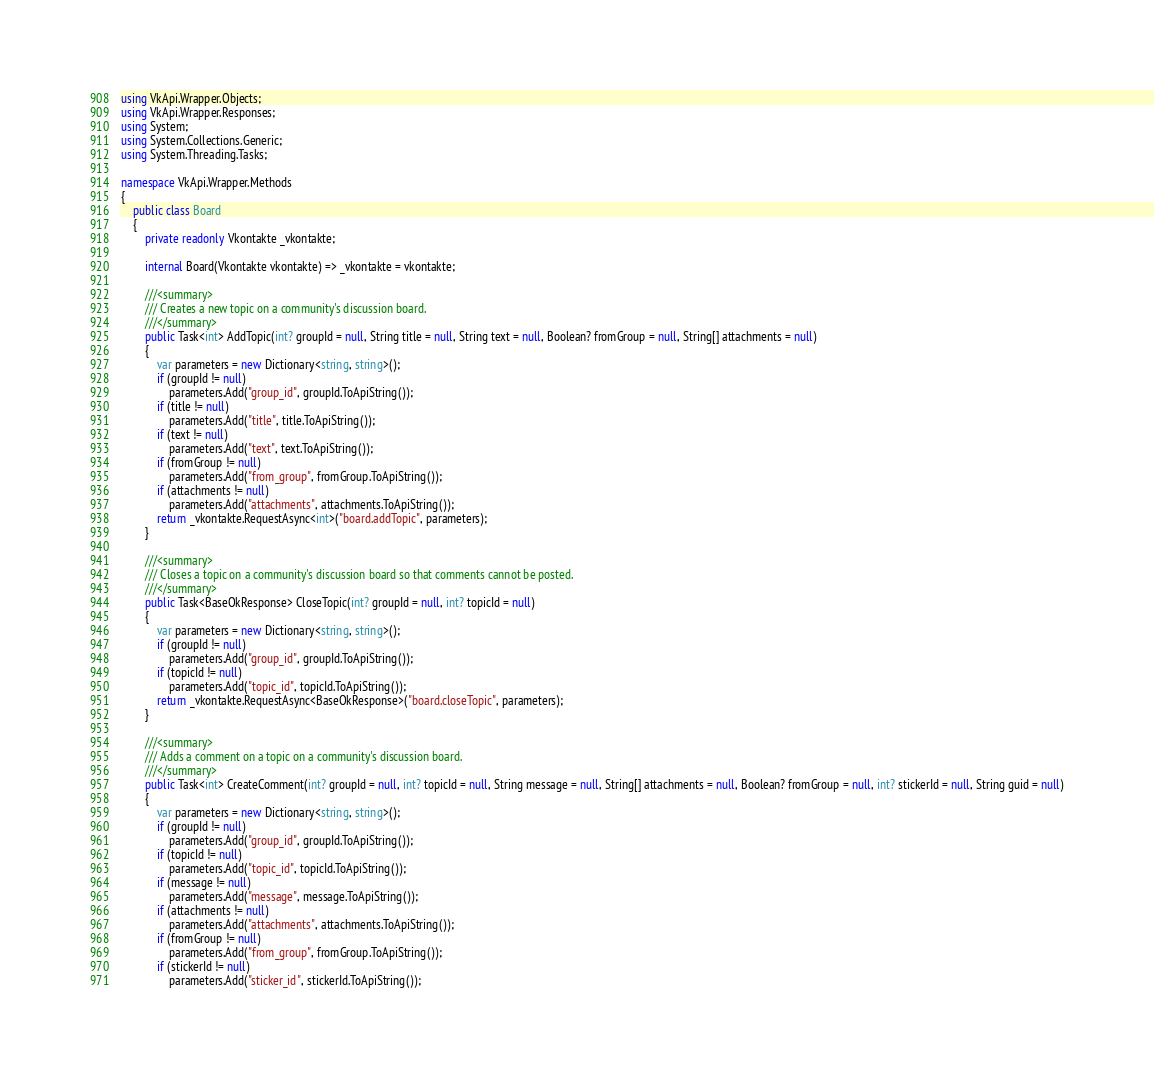Convert code to text. <code><loc_0><loc_0><loc_500><loc_500><_C#_>using VkApi.Wrapper.Objects;
using VkApi.Wrapper.Responses;
using System;
using System.Collections.Generic;
using System.Threading.Tasks;

namespace VkApi.Wrapper.Methods
{
    public class Board
    {
        private readonly Vkontakte _vkontakte;

        internal Board(Vkontakte vkontakte) => _vkontakte = vkontakte;

        ///<summary>
        /// Creates a new topic on a community's discussion board.
        ///</summary>
        public Task<int> AddTopic(int? groupId = null, String title = null, String text = null, Boolean? fromGroup = null, String[] attachments = null)
        {
            var parameters = new Dictionary<string, string>();
            if (groupId != null)
                parameters.Add("group_id", groupId.ToApiString());
            if (title != null)
                parameters.Add("title", title.ToApiString());
            if (text != null)
                parameters.Add("text", text.ToApiString());
            if (fromGroup != null)
                parameters.Add("from_group", fromGroup.ToApiString());
            if (attachments != null)
                parameters.Add("attachments", attachments.ToApiString());
            return _vkontakte.RequestAsync<int>("board.addTopic", parameters);
        }

        ///<summary>
        /// Closes a topic on a community's discussion board so that comments cannot be posted.
        ///</summary>
        public Task<BaseOkResponse> CloseTopic(int? groupId = null, int? topicId = null)
        {
            var parameters = new Dictionary<string, string>();
            if (groupId != null)
                parameters.Add("group_id", groupId.ToApiString());
            if (topicId != null)
                parameters.Add("topic_id", topicId.ToApiString());
            return _vkontakte.RequestAsync<BaseOkResponse>("board.closeTopic", parameters);
        }

        ///<summary>
        /// Adds a comment on a topic on a community's discussion board.
        ///</summary>
        public Task<int> CreateComment(int? groupId = null, int? topicId = null, String message = null, String[] attachments = null, Boolean? fromGroup = null, int? stickerId = null, String guid = null)
        {
            var parameters = new Dictionary<string, string>();
            if (groupId != null)
                parameters.Add("group_id", groupId.ToApiString());
            if (topicId != null)
                parameters.Add("topic_id", topicId.ToApiString());
            if (message != null)
                parameters.Add("message", message.ToApiString());
            if (attachments != null)
                parameters.Add("attachments", attachments.ToApiString());
            if (fromGroup != null)
                parameters.Add("from_group", fromGroup.ToApiString());
            if (stickerId != null)
                parameters.Add("sticker_id", stickerId.ToApiString());</code> 